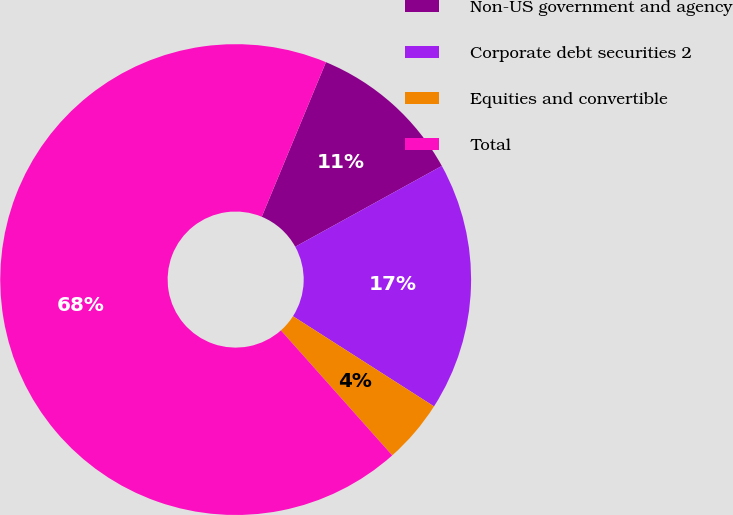Convert chart to OTSL. <chart><loc_0><loc_0><loc_500><loc_500><pie_chart><fcel>Non-US government and agency<fcel>Corporate debt securities 2<fcel>Equities and convertible<fcel>Total<nl><fcel>10.72%<fcel>17.07%<fcel>4.37%<fcel>67.84%<nl></chart> 